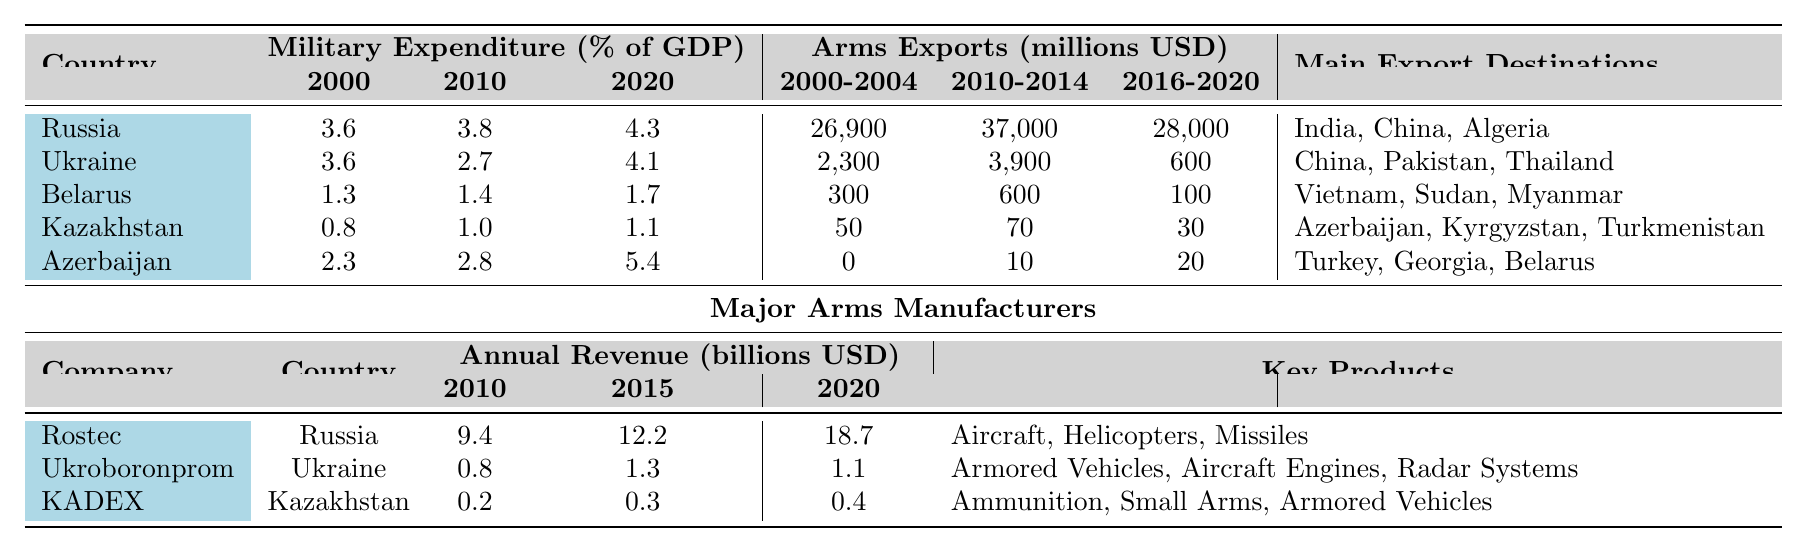What was Russia's military expenditure as a percentage of GDP in 2010? The table lists Russia's military expenditure in 2010 as 3.8% of GDP.
Answer: 3.8% Which country had the highest arms exports in 2010-2014? The table shows that Russia had the highest arms exports during this period at 37,000 million USD.
Answer: Russia What is the difference in military expenditure (% of GDP) for Azerbaijan from 2000 to 2020? The military expenditure for Azerbaijan in 2000 was 2.3%, and in 2020, it was 5.4%. The difference is 5.4% - 2.3% = 3.1%.
Answer: 3.1% Which country had the lowest arms exports in the 2016-2020 period? According to the table, Kazakhstan had the lowest arms exports in the 2016-2020 period at 30 million USD.
Answer: Kazakhstan What was the average military expenditure as a percentage of GDP for all countries in 2020? The values for military expenditure in 2020 are as follows: Russia (4.3%), Ukraine (4.1%), Belarus (1.7%), Kazakhstan (1.1%), and Azerbaijan (5.4%). The average is (4.3 + 4.1 + 1.7 + 1.1 + 5.4) / 5 = 2.52%.
Answer: 2.52% Did any country have a decrease in arms exports from the period of 2010-2014 to 2016-2020? Yes, Ukraine's arms exports decreased from 3,900 million USD in 2010-2014 to 600 million USD in 2016-2020.
Answer: Yes Identify the main export destination for Belarus' arms exports. The table indicates that the main export destinations for Belarus were Vietnam, Sudan, and Myanmar.
Answer: Vietnam, Sudan, Myanmar Who had the highest annual revenue in the arms manufacturing sector in 2020? The table states that Rostec from Russia had the highest annual revenue of 18.7 billion USD in 2020, compared to other manufacturers.
Answer: Rostec What percentage of GDP did Kazakhstan allocate to military expenditure in 2000? The table clearly shows that Kazakhstan's military expenditure in 2000 was 0.8% of GDP.
Answer: 0.8% Which country showed a significant increase in military expenditure from 2010 to 2020? Azerbaijan increased its military expenditure from 2.8% in 2010 to 5.4% in 2020, which is a significant increase.
Answer: Azerbaijan How many key products does Ukroboronprom manufacture according to the table? The table lists Ukroboronprom's key products as Armored Vehicles, Aircraft Engines, and Radar Systems, totaling three key products.
Answer: 3 